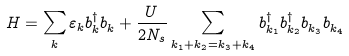<formula> <loc_0><loc_0><loc_500><loc_500>H = \sum _ { k } \varepsilon _ { k } b ^ { \dagger } _ { k } b ^ { \, } _ { k } + \frac { U } { 2 N _ { s } } \sum _ { k _ { 1 } + k _ { 2 } = k _ { 3 } + k _ { 4 } } b ^ { \dagger } _ { k _ { 1 } } b ^ { \dagger } _ { k _ { 2 } } b ^ { \, } _ { k _ { 3 } } b ^ { \, } _ { k _ { 4 } }</formula> 